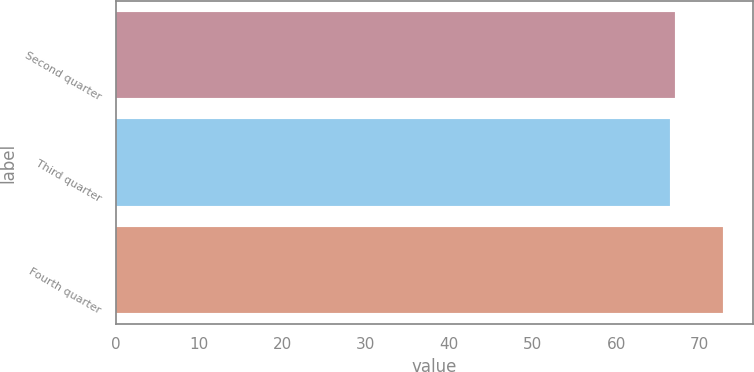Convert chart. <chart><loc_0><loc_0><loc_500><loc_500><bar_chart><fcel>Second quarter<fcel>Third quarter<fcel>Fourth quarter<nl><fcel>67.11<fcel>66.48<fcel>72.81<nl></chart> 